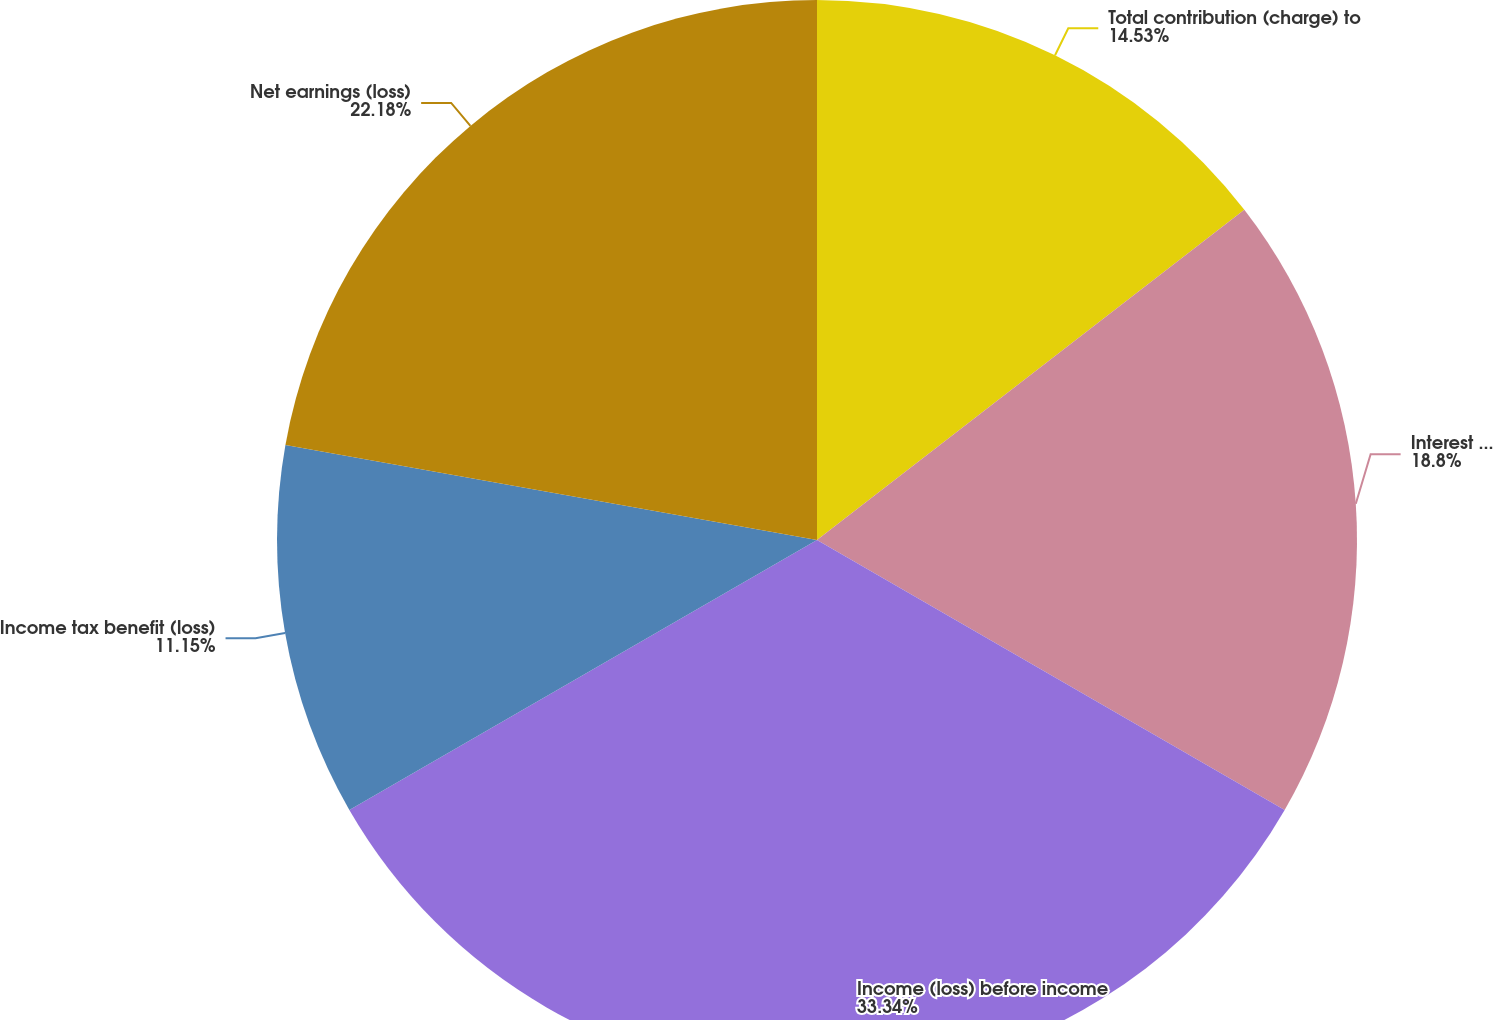Convert chart to OTSL. <chart><loc_0><loc_0><loc_500><loc_500><pie_chart><fcel>Total contribution (charge) to<fcel>Interest expense net of<fcel>Income (loss) before income<fcel>Income tax benefit (loss)<fcel>Net earnings (loss)<nl><fcel>14.53%<fcel>18.8%<fcel>33.33%<fcel>11.15%<fcel>22.18%<nl></chart> 